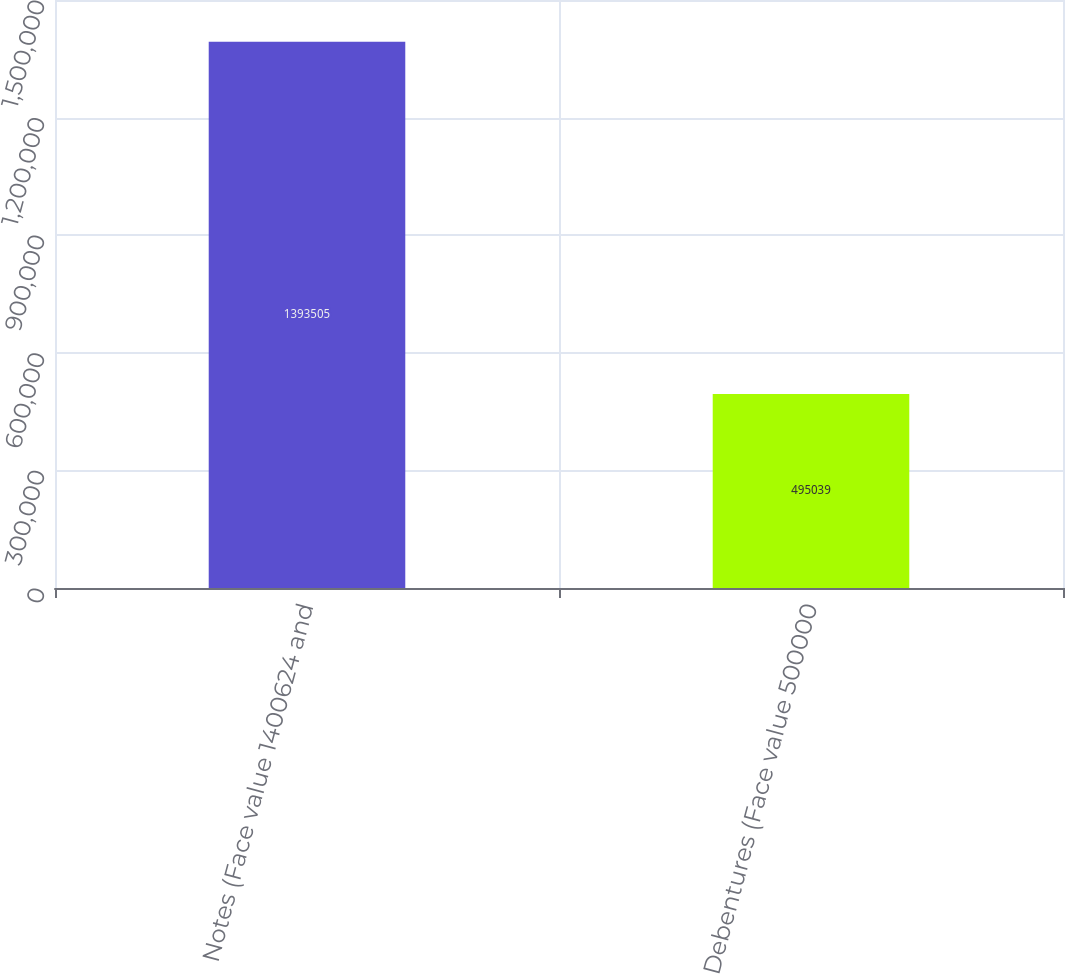Convert chart. <chart><loc_0><loc_0><loc_500><loc_500><bar_chart><fcel>Notes (Face value 1400624 and<fcel>Debentures (Face value 500000<nl><fcel>1.3935e+06<fcel>495039<nl></chart> 